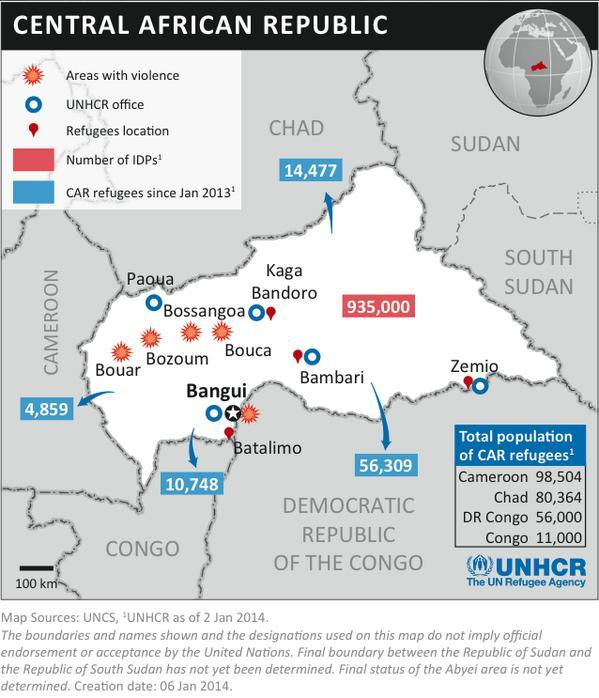What is the total number of CAR refugees since Jan 2013 in Central African Republic?
Answer the question with a short phrase. 86,393 What is the total number of CAR refugees in Congo and DR Congo? 67,000 What is the total number of CAR refugees in Congo and Chad? 91,364 What is the total number of CAR refugees in Congo and Cameroon? 109,504 What is the number of IDPs since Jan 2013 in Central African Republic? 935,000 What is the total number of CAR refugees in Cameroon and Chad? 178,868 How many UNHCR offices are mapped in Central African Republic? 5 How many areas are mapped in the infographics for violence? 5 